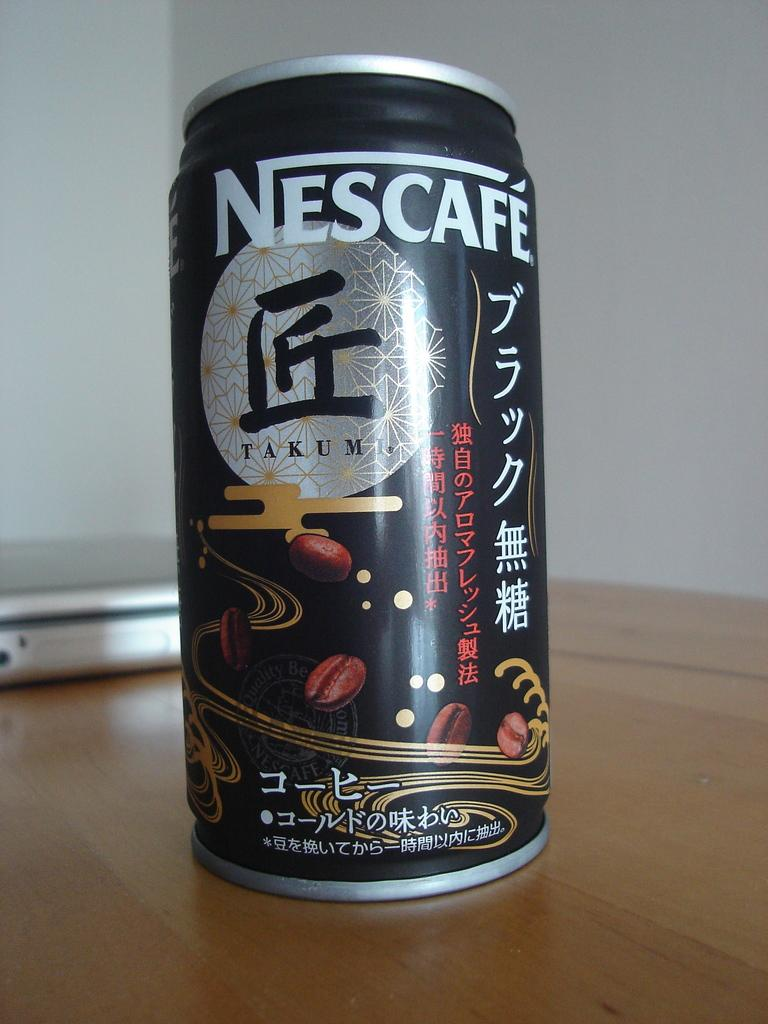<image>
Create a compact narrative representing the image presented. A can of NESCAFE is shown with coffee beans on it. 